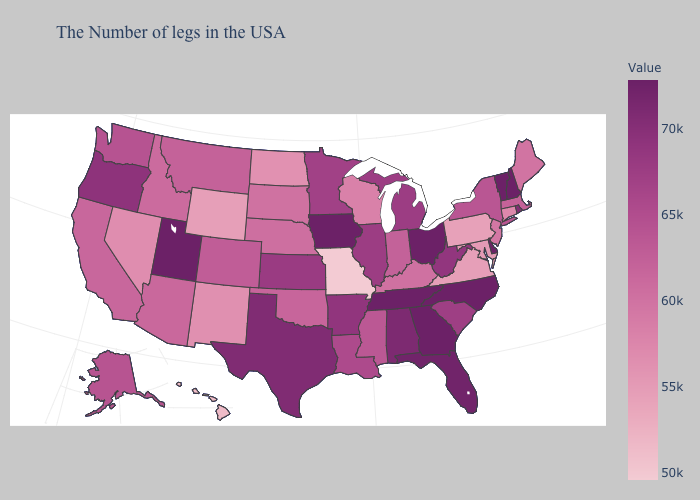Which states have the lowest value in the West?
Be succinct. Hawaii. Among the states that border Delaware , which have the lowest value?
Short answer required. Pennsylvania. Does Wisconsin have the highest value in the MidWest?
Concise answer only. No. Which states have the lowest value in the USA?
Write a very short answer. Missouri. Which states have the lowest value in the USA?
Quick response, please. Missouri. Among the states that border Nebraska , does Kansas have the lowest value?
Keep it brief. No. 